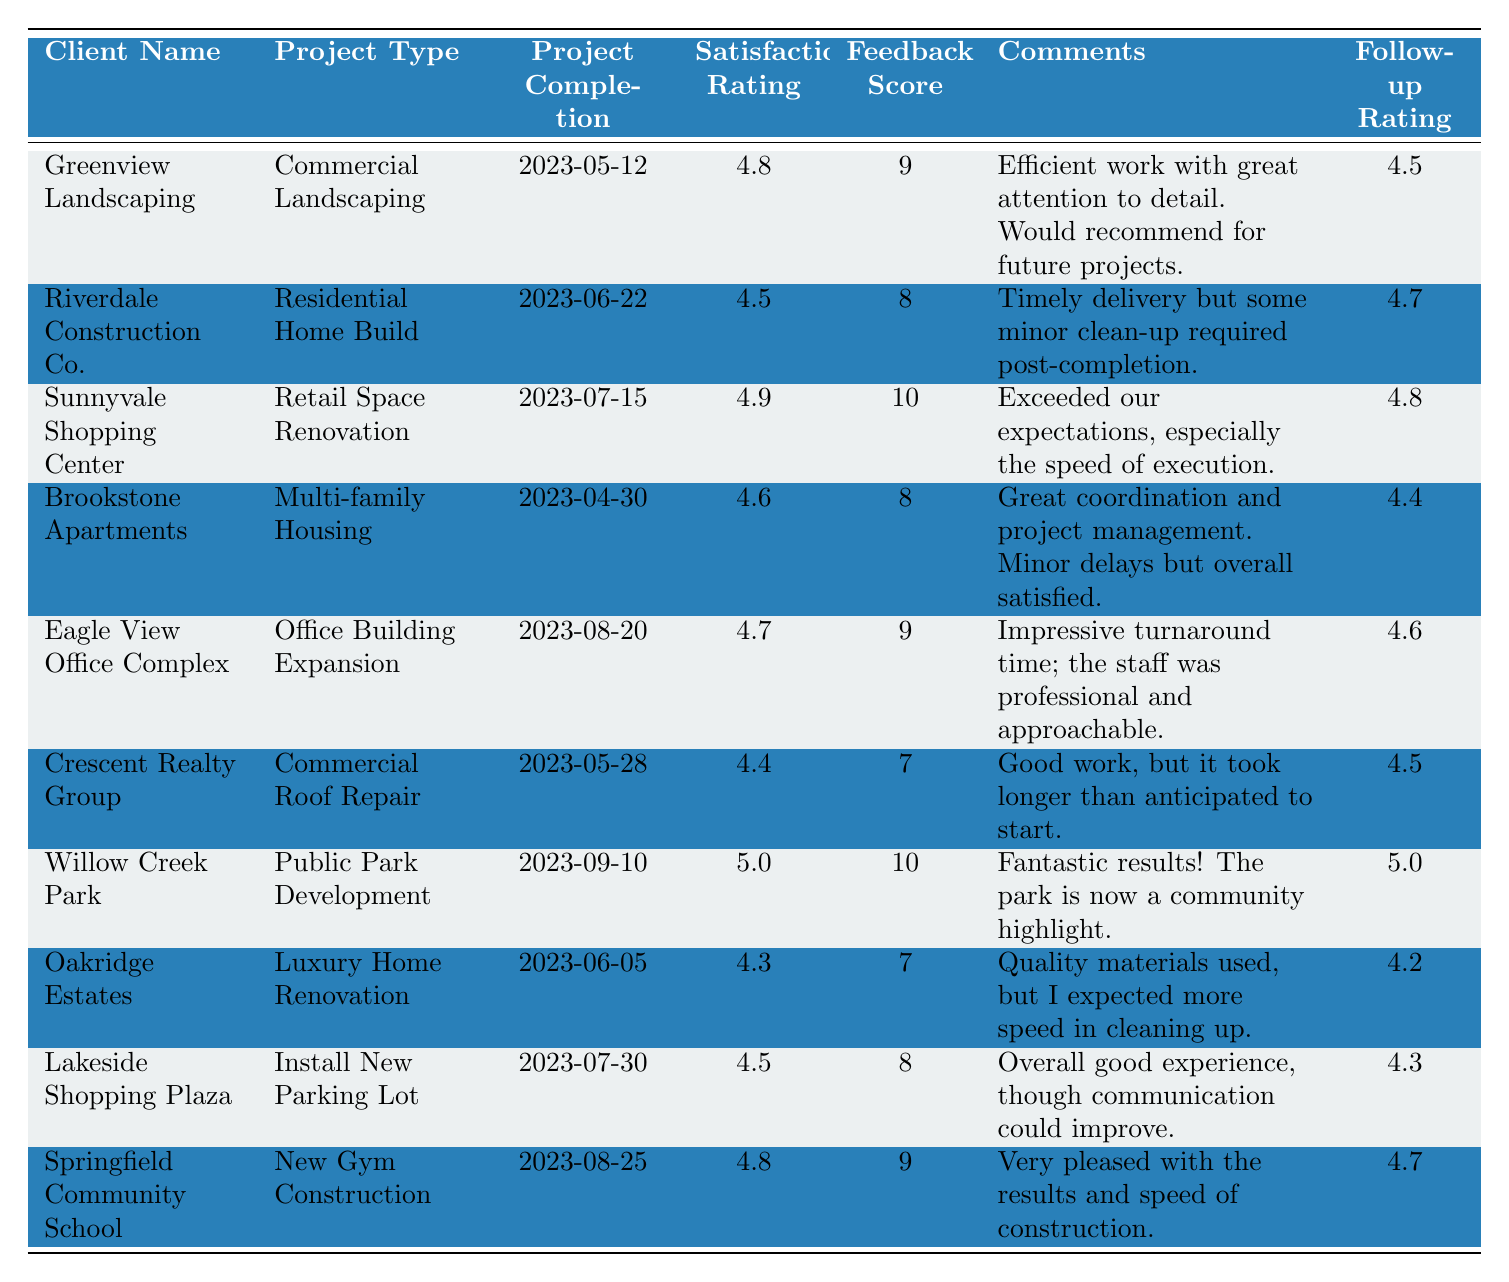What is the highest satisfaction rating among the clients? The table shows satisfaction ratings for each client. Scanning through the satisfaction ratings, the highest number is 5.0 for Willow Creek Park.
Answer: 5.0 Which project had the lowest feedback score? The feedback scores are listed for each project. The lowest score is 7, which belongs to both Crescent Realty Group and Oakridge Estates.
Answer: 7 What is the average satisfaction rating of all the projects? To find the average satisfaction rating, we total the ratings (4.8 + 4.5 + 4.9 + 4.6 + 4.7 + 4.4 + 5.0 + 4.3 + 4.5 + 4.8 = 46.5) and divide by the number of projects (10): 46.5 / 10 = 4.65.
Answer: 4.65 Did any client give a feedback score of 10? By checking the feedback scores, we see that both Sunnyvale Shopping Center and Willow Creek Park received a feedback score of 10. Thus, the answer is yes.
Answer: Yes Which project type had the highest follow-up rating? The follow-up ratings are found in the last column. Scanning through, Willow Creek Park shows a follow-up rating of 5.0, which is the highest in that column.
Answer: 5.0 What is the difference in satisfaction rating between the best-rated project and the lowest-rated project? The highest satisfaction rating is 5.0 (Willow Creek Park) and the lowest is 4.3 (Oakridge Estates). The difference is calculated as 5.0 - 4.3 = 0.7.
Answer: 0.7 How many projects received a satisfaction rating above 4.5? Looking at the satisfaction ratings, 6 projects have ratings above 4.5: Greenview Landscaping, Sunnyvale Shopping Center, Eagle View Office Complex, Willow Creek Park, Springfield Community School, and Riverdale Construction Co.
Answer: 6 Which client had the fastest project completion date? The projects listed with their completion dates show that the earliest date is 2023-04-30 for Brookstone Apartments.
Answer: Brookstone Apartments What is the median feedback score of the projects? To find the median, we first list the feedback scores in order: 7, 7, 8, 8, 8, 9, 9, 9, 10, 10. As there are 10 scores, the median is the average of the 5th and 6th values (8 and 9): (8 + 9) / 2 = 8.5.
Answer: 8.5 Which project had the best comments? The comments can be evaluated for their positivity. Willow Creek Park's comments are the most positive: "Fantastic results! The park is now a community highlight."
Answer: Willow Creek Park 